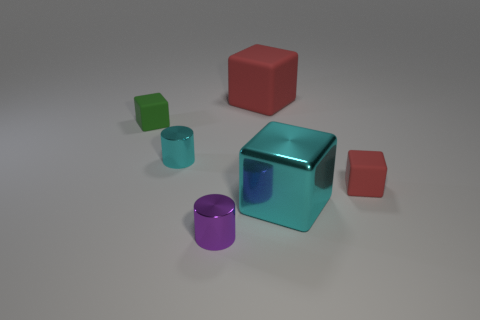Add 1 cubes. How many objects exist? 7 Subtract all blocks. How many objects are left? 2 Subtract 0 green balls. How many objects are left? 6 Subtract all big rubber things. Subtract all large red rubber blocks. How many objects are left? 4 Add 2 small cyan things. How many small cyan things are left? 3 Add 3 big red matte cubes. How many big red matte cubes exist? 4 